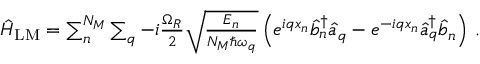<formula> <loc_0><loc_0><loc_500><loc_500>\begin{array} { r } { \hat { H } _ { L M } = \sum _ { n } ^ { N _ { M } } \sum _ { q } - i \frac { \Omega _ { R } } { 2 } \sqrt { \frac { E _ { n } } { N _ { M } \hbar { \omega } _ { q } } } \left ( e ^ { i q x _ { n } } \hat { b } _ { n } ^ { \dagger } \hat { a } _ { q } - e ^ { - i q x _ { n } } \hat { a } _ { q } ^ { \dagger } \hat { b } _ { n } \right ) \, . } \end{array}</formula> 